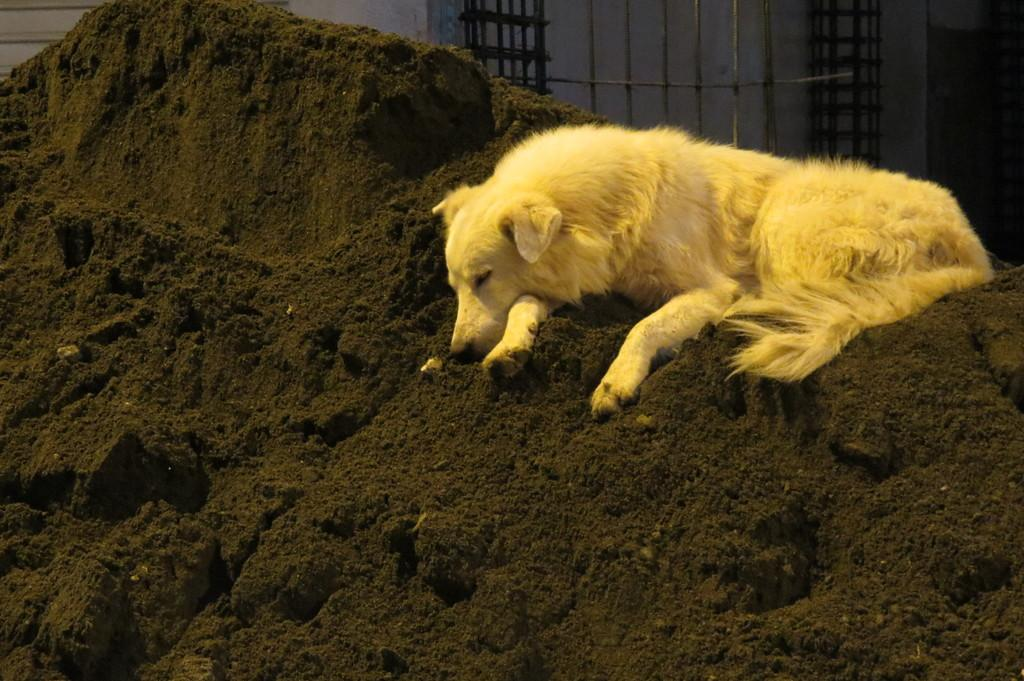What is the main substance present in the image? There is mud in the image. Can you describe any animals in the image? There is a yellow color dog in the image. What can be seen in the background of the image? There is a wall in the background of the image. How would you describe the lighting in the image? The image is a little dark. What type of representative is present in the image? There is no representative present in the image; it features mud and a yellow dog. What suggestion can be made based on the image? The image does not provide any specific suggestions or recommendations. 